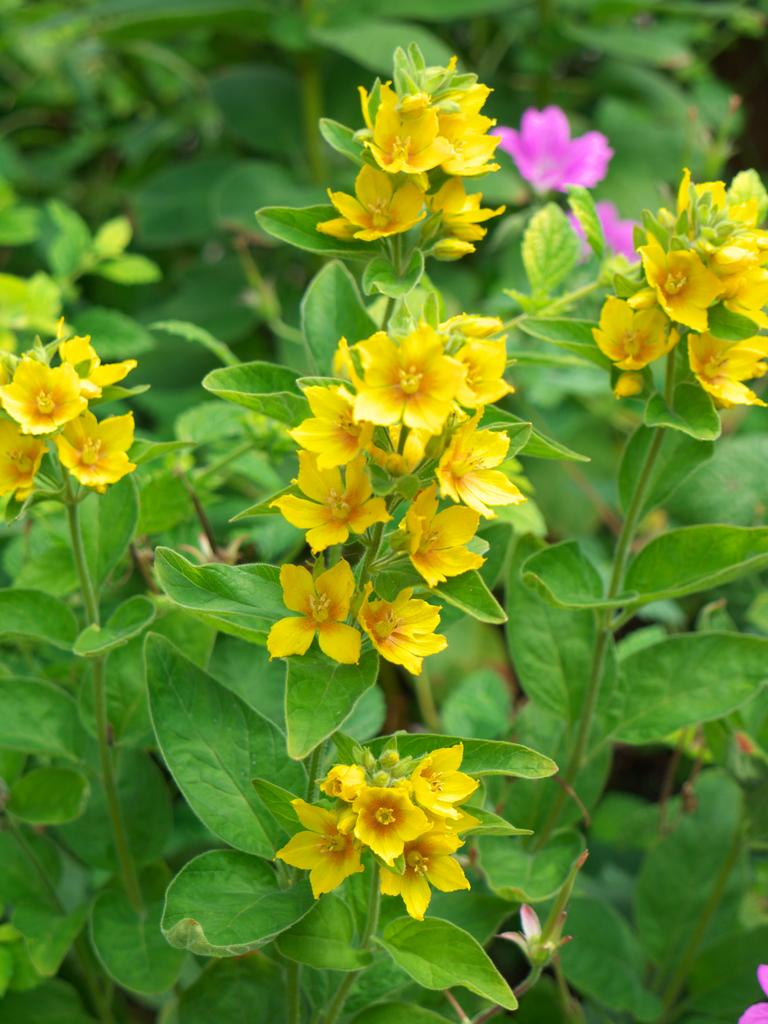What type of plants can be seen in the image? There are plants with flowers in the image. What color are the flowers on the plants? The flowers are yellow in color. What other vegetation is present in the image? There are trees in the image. What is the color of the trees in the image? The trees are green in color. Where is the drain located in the image? There is no drain present in the image. What type of straw is used to water the plants in the image? There is no straw visible in the image, and it is not mentioned that the plants are being watered. 